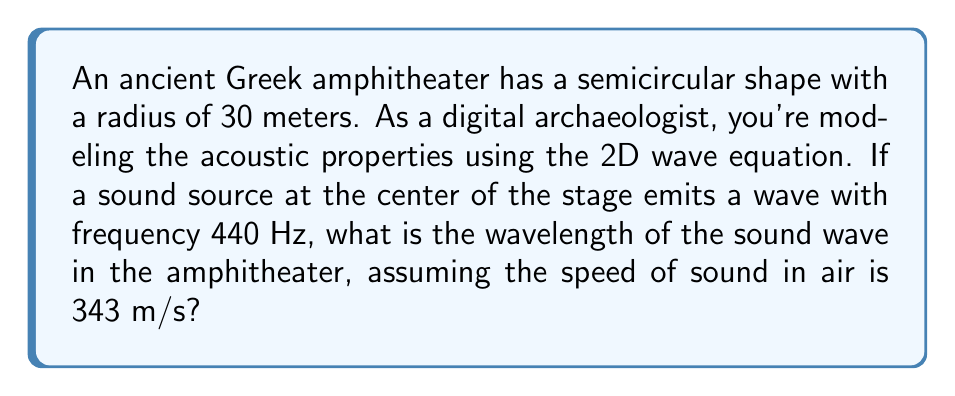Can you solve this math problem? To solve this problem, we'll use the wave equation and the relationship between wave speed, frequency, and wavelength.

1. The wave equation in 2D polar coordinates for a circular wavefront is:

   $$\frac{\partial^2 u}{\partial r^2} + \frac{1}{r}\frac{\partial u}{\partial r} - \frac{1}{c^2}\frac{\partial^2 u}{\partial t^2} = 0$$

   where $u$ is the wave amplitude, $r$ is the radial distance, $t$ is time, and $c$ is the wave speed.

2. For a harmonic wave with angular frequency $\omega$, the solution has the form:

   $$u(r,t) = A J_0(kr) e^{i\omega t}$$

   where $J_0$ is the Bessel function of the first kind of order zero, $k$ is the wavenumber, and $A$ is the amplitude.

3. The wavenumber $k$ is related to the wavelength $\lambda$ by:

   $$k = \frac{2\pi}{\lambda}$$

4. The wave speed $c$, frequency $f$, and wavelength $\lambda$ are related by:

   $$c = f\lambda$$

5. We are given:
   - Speed of sound: $c = 343$ m/s
   - Frequency: $f = 440$ Hz

6. Rearranging the equation from step 4:

   $$\lambda = \frac{c}{f}$$

7. Substituting the values:

   $$\lambda = \frac{343 \text{ m/s}}{440 \text{ Hz}} = 0.78\text{ m}$$

Thus, the wavelength of the sound wave in the amphitheater is 0.78 meters.
Answer: 0.78 m 